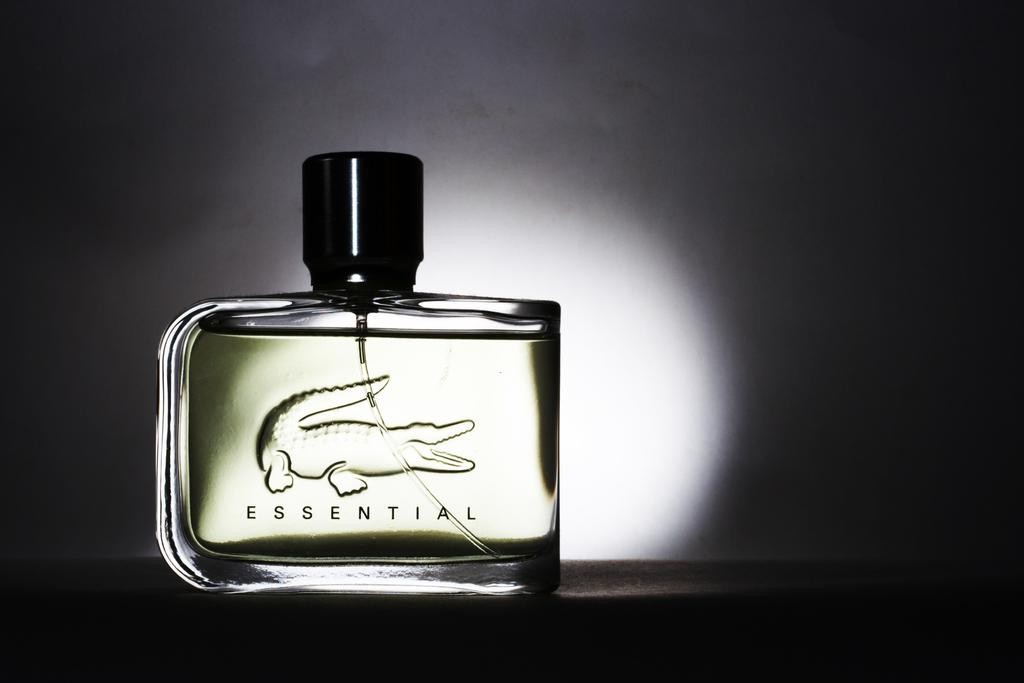<image>
Describe the image concisely. a perfume bottle saying Essential with a crocodile 